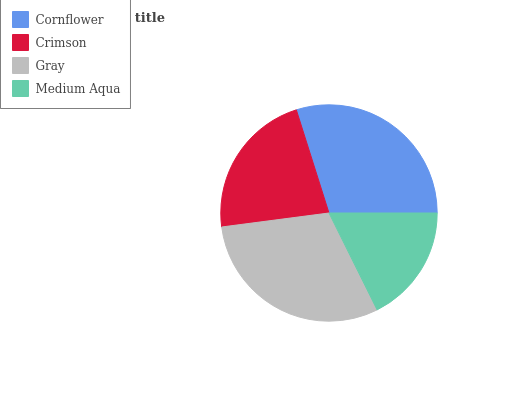Is Medium Aqua the minimum?
Answer yes or no. Yes. Is Gray the maximum?
Answer yes or no. Yes. Is Crimson the minimum?
Answer yes or no. No. Is Crimson the maximum?
Answer yes or no. No. Is Cornflower greater than Crimson?
Answer yes or no. Yes. Is Crimson less than Cornflower?
Answer yes or no. Yes. Is Crimson greater than Cornflower?
Answer yes or no. No. Is Cornflower less than Crimson?
Answer yes or no. No. Is Cornflower the high median?
Answer yes or no. Yes. Is Crimson the low median?
Answer yes or no. Yes. Is Gray the high median?
Answer yes or no. No. Is Cornflower the low median?
Answer yes or no. No. 